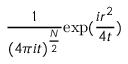<formula> <loc_0><loc_0><loc_500><loc_500>\frac { 1 } { ( 4 \pi i t ) ^ { \frac { N } { 2 } } } e x p ( \frac { i r ^ { 2 } } { 4 t } )</formula> 